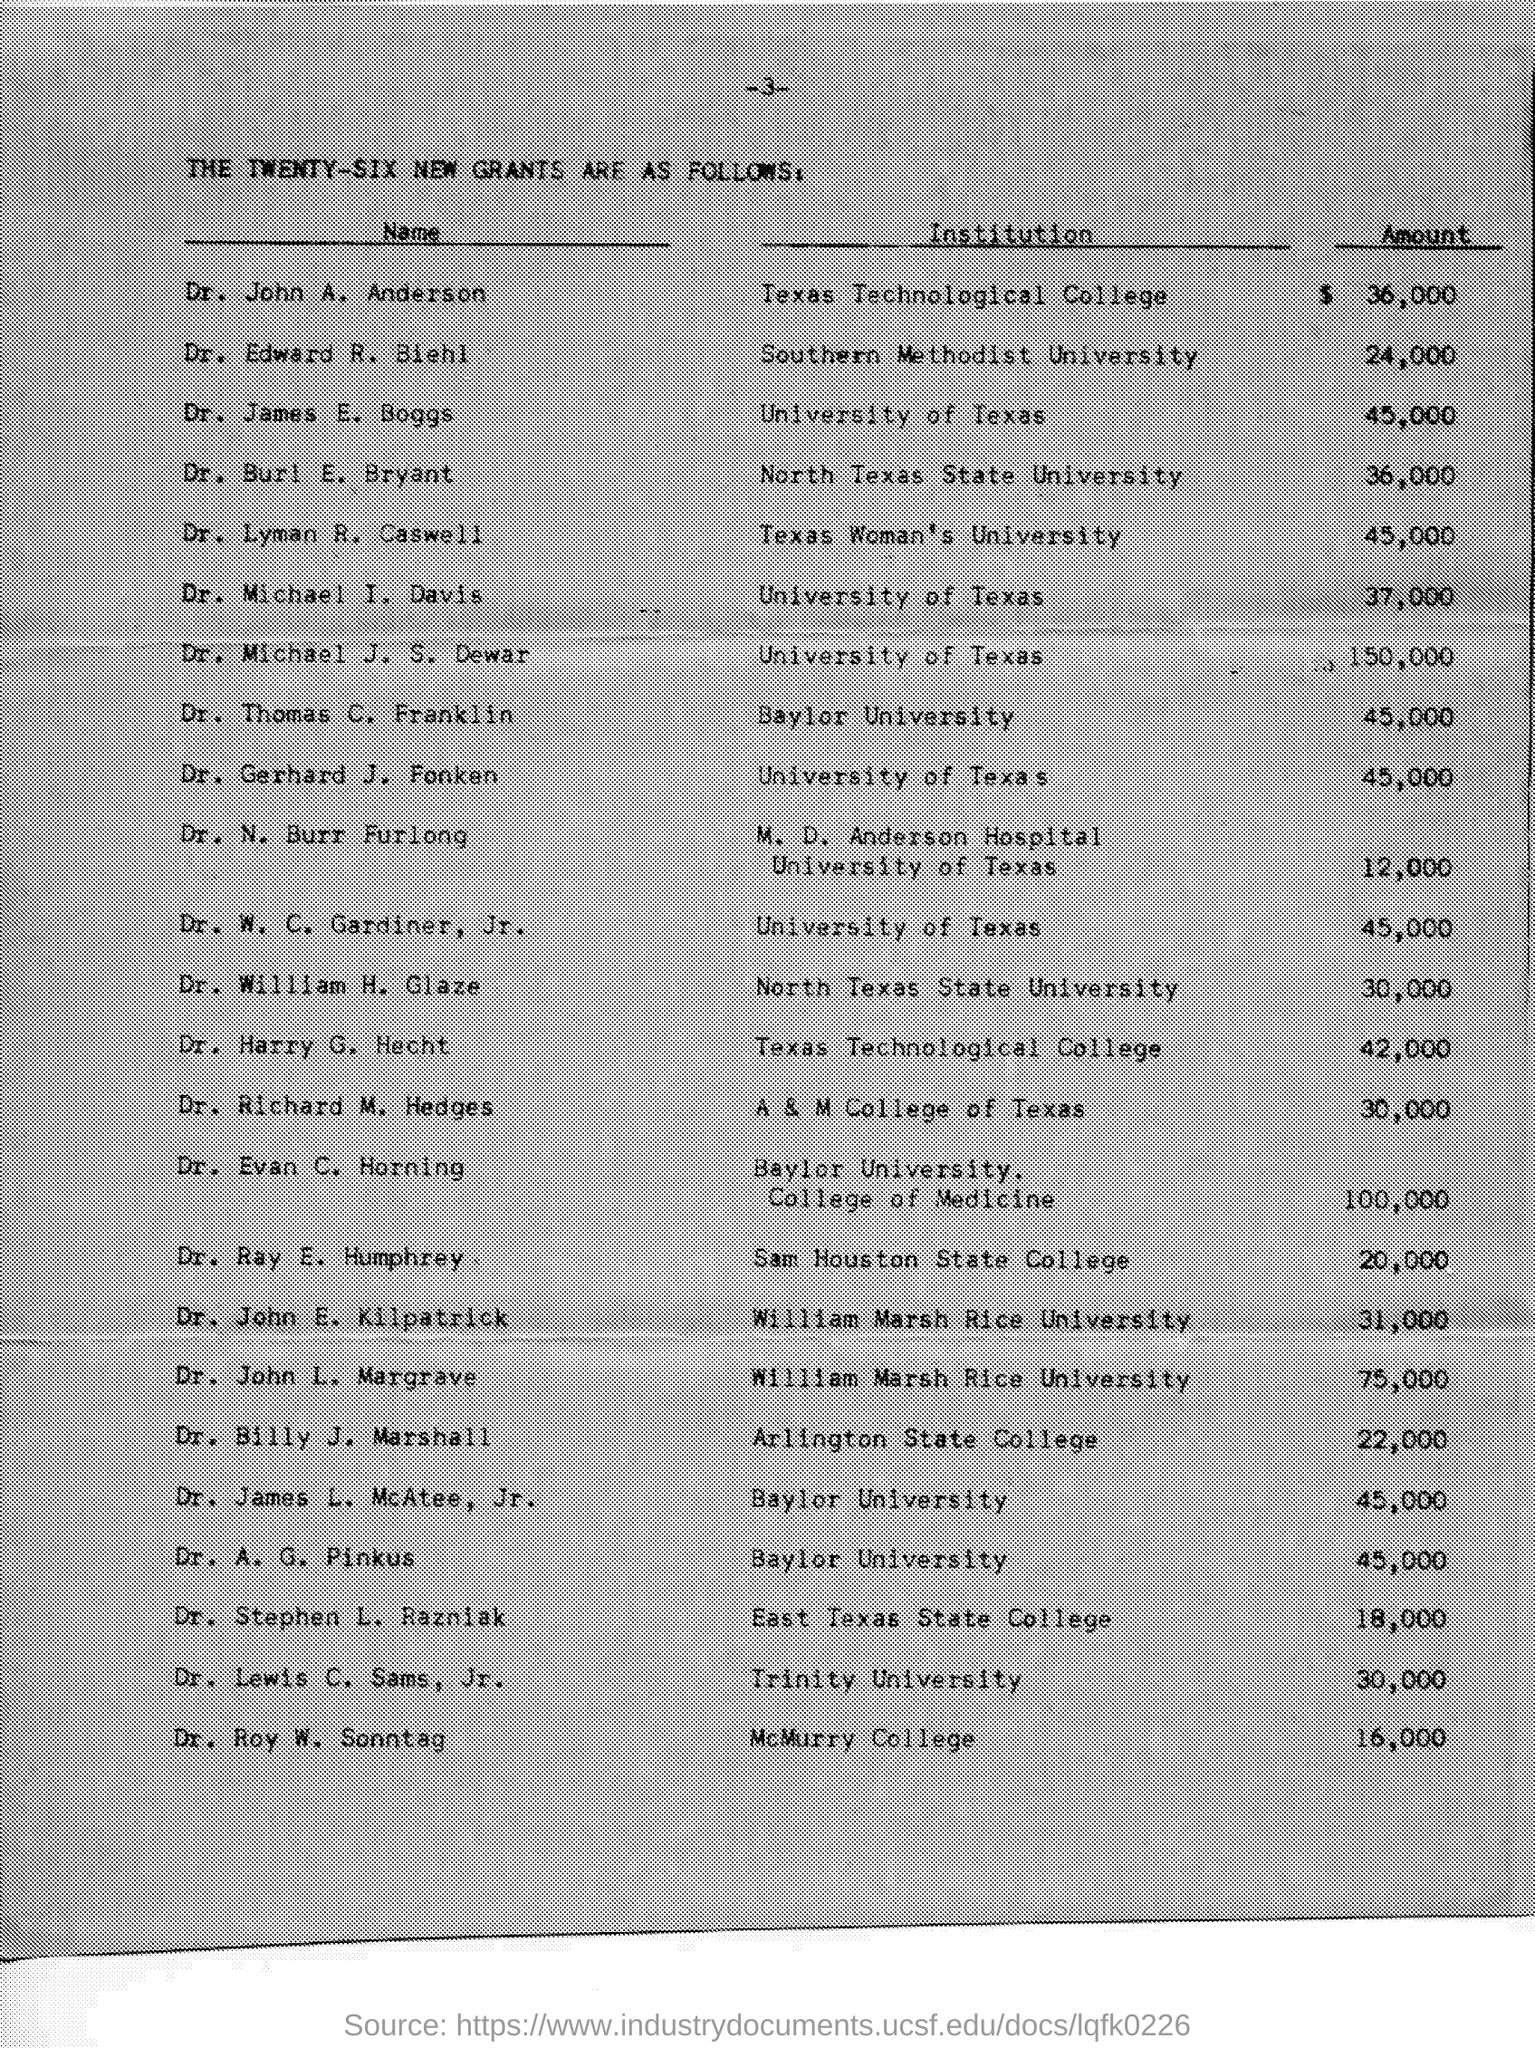Highlight a few significant elements in this photo. Dr. A. G. Pinkus is affiliated with Baylor University. Dr. Edward R. Biehl is affiliated with Southern Methodist University. Dr. Thomas C. Franklin's institution is Baylor University. Dr. Michael J. S. Dewar is affiliated with the University of Texas as an institution. Dr. Lyman R. Caswell is affiliated with Texas Woman's University, an institution. 